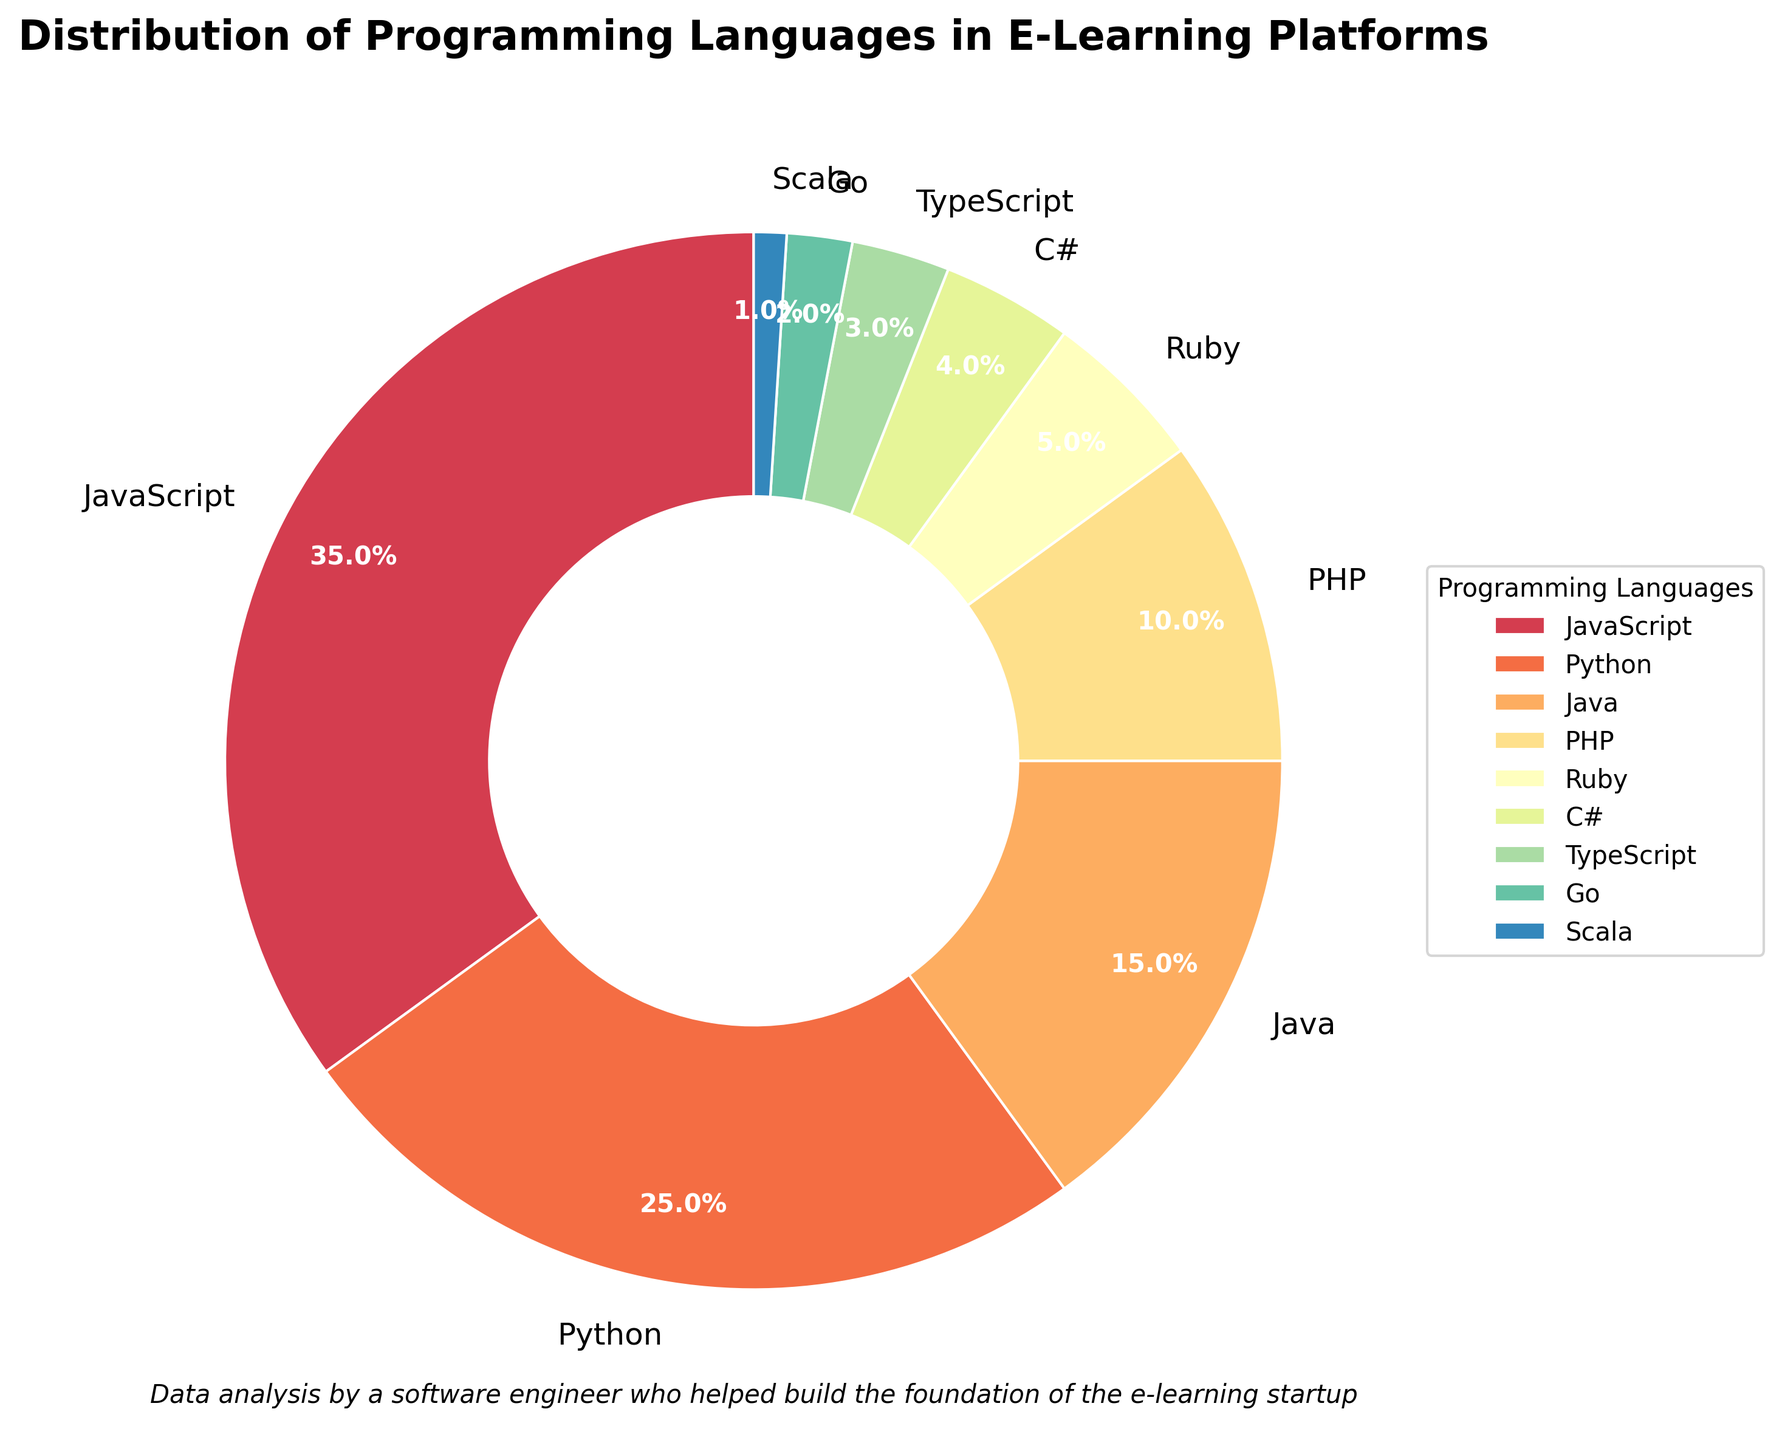Which programming language has the highest percentage? By examining the pie chart, we can determine which segment has the largest size and label it accordingly. The largest segment represents JavaScript with a percentage of 35%.
Answer: JavaScript What is the combined percentage of Python and PHP usage? First, identify the percentage of Python and PHP from the chart: Python (25%) and PHP (10%). Summing these values gives us the combined percentage: 25% + 10% = 35%.
Answer: 35% Are there more platforms using Java or Ruby? Locate the segments for Java and Ruby on the pie chart. Java has a percentage of 15% while Ruby has 5%. Java's percentage is higher than Ruby's, indicating more platforms use Java.
Answer: Java What is the percentage difference between JavaScript and C#? Identify the percentages for JavaScript and C# from the chart: JavaScript (35%) and C# (4%). Subtract the smaller percentage from the larger one: 35% - 4% = 31%.
Answer: 31% Which programming languages together constitute over half of the total usage? Sum the percentages of the top segments until exceeding 50%. JavaScript (35%) + Python (25%) = 60%, which is over half. Thus, JavaScript and Python together constitute over half of the usage.
Answer: JavaScript and Python Which segment is represented by the smallest percentage and what is it? Identify the smallest segment in the pie chart, which is labeled Scala with a percentage of 1%.
Answer: Scala Is the percentage of TypeScript usage more or less than twice the percentage of Go usage? Identify the percentages: TypeScript (3%) and Go (2%). Twice the percentage of Go is 2% * 2 = 4%. Since 3% (TypeScript) is less than 4%, TypeScript usage is less than twice the percentage of Go usage.
Answer: Less If Ruby's percentage doubled, would it surpass PHP's current percentage? Ruby has a current percentage of 5%. Doubling this gives 5% * 2 = 10%. Comparing it with PHP's percentage (10%) shows they would be equal, not surpassing.
Answer: No, they would be equal What is the average percentage of the bottom three languages? Identify the bottom three languages: Scala (1%), Go (2%), and TypeScript (3%). Calculate the average: (1% + 2% + 3%) / 3 = 6% / 3 = 2%.
Answer: 2% Which color segment represents the second highest programming language usage? The second highest segment is for Python, which has a specific color assigned to it in the pie chart. Locate the second largest segment, representing Python's 25%.
Answer: Python 